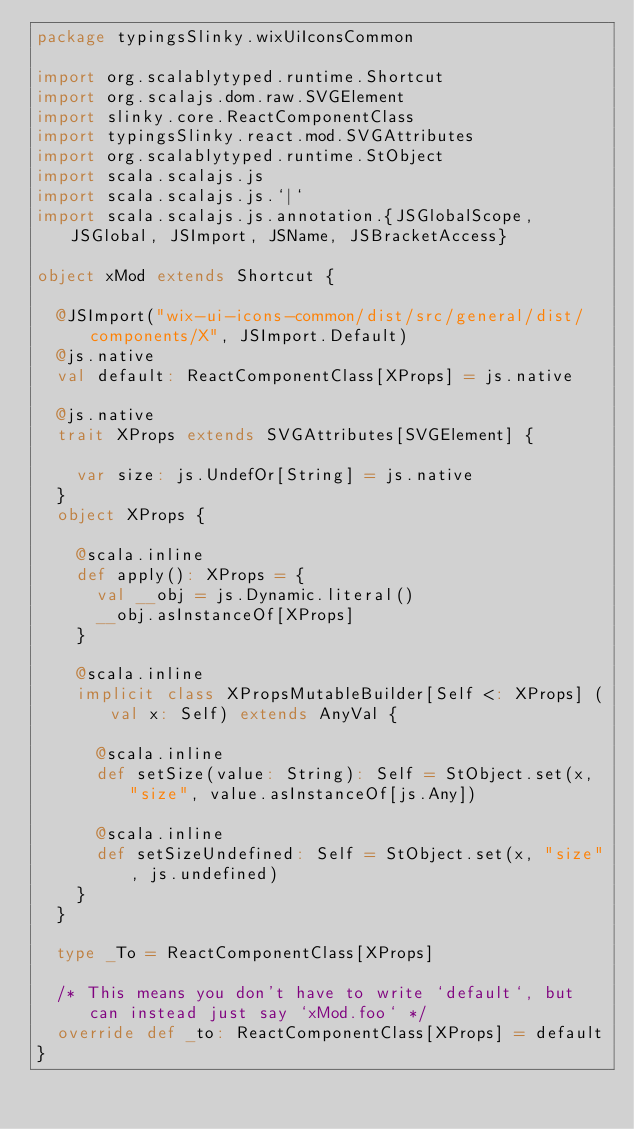Convert code to text. <code><loc_0><loc_0><loc_500><loc_500><_Scala_>package typingsSlinky.wixUiIconsCommon

import org.scalablytyped.runtime.Shortcut
import org.scalajs.dom.raw.SVGElement
import slinky.core.ReactComponentClass
import typingsSlinky.react.mod.SVGAttributes
import org.scalablytyped.runtime.StObject
import scala.scalajs.js
import scala.scalajs.js.`|`
import scala.scalajs.js.annotation.{JSGlobalScope, JSGlobal, JSImport, JSName, JSBracketAccess}

object xMod extends Shortcut {
  
  @JSImport("wix-ui-icons-common/dist/src/general/dist/components/X", JSImport.Default)
  @js.native
  val default: ReactComponentClass[XProps] = js.native
  
  @js.native
  trait XProps extends SVGAttributes[SVGElement] {
    
    var size: js.UndefOr[String] = js.native
  }
  object XProps {
    
    @scala.inline
    def apply(): XProps = {
      val __obj = js.Dynamic.literal()
      __obj.asInstanceOf[XProps]
    }
    
    @scala.inline
    implicit class XPropsMutableBuilder[Self <: XProps] (val x: Self) extends AnyVal {
      
      @scala.inline
      def setSize(value: String): Self = StObject.set(x, "size", value.asInstanceOf[js.Any])
      
      @scala.inline
      def setSizeUndefined: Self = StObject.set(x, "size", js.undefined)
    }
  }
  
  type _To = ReactComponentClass[XProps]
  
  /* This means you don't have to write `default`, but can instead just say `xMod.foo` */
  override def _to: ReactComponentClass[XProps] = default
}
</code> 